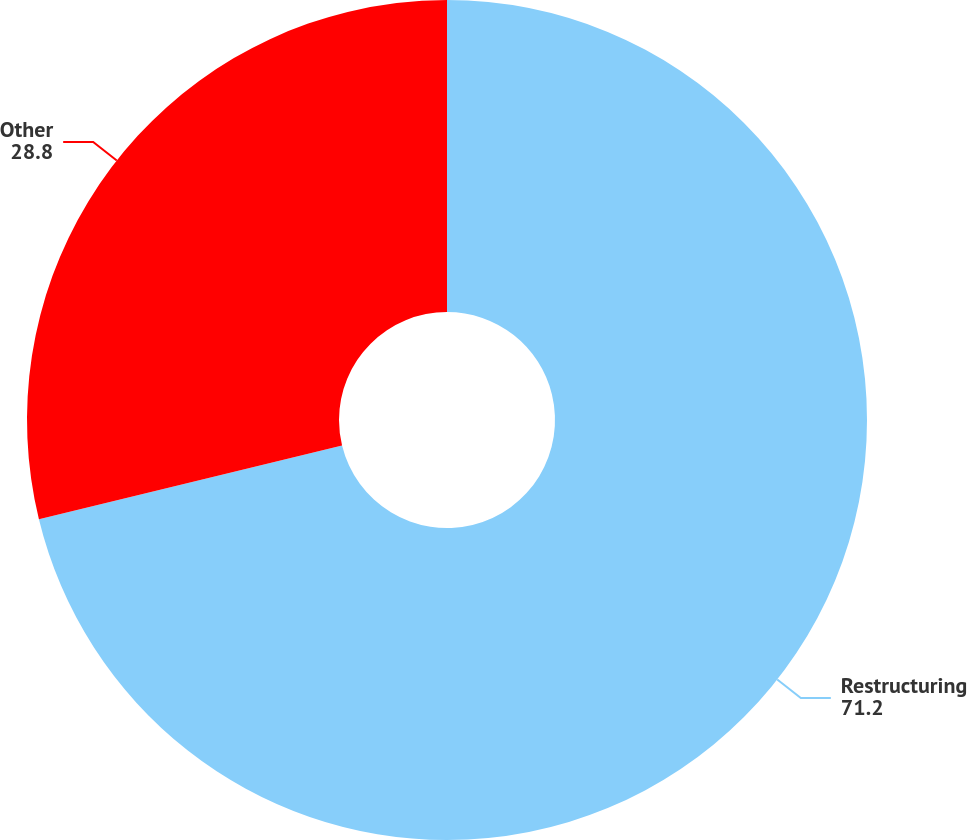Convert chart to OTSL. <chart><loc_0><loc_0><loc_500><loc_500><pie_chart><fcel>Restructuring<fcel>Other<nl><fcel>71.2%<fcel>28.8%<nl></chart> 